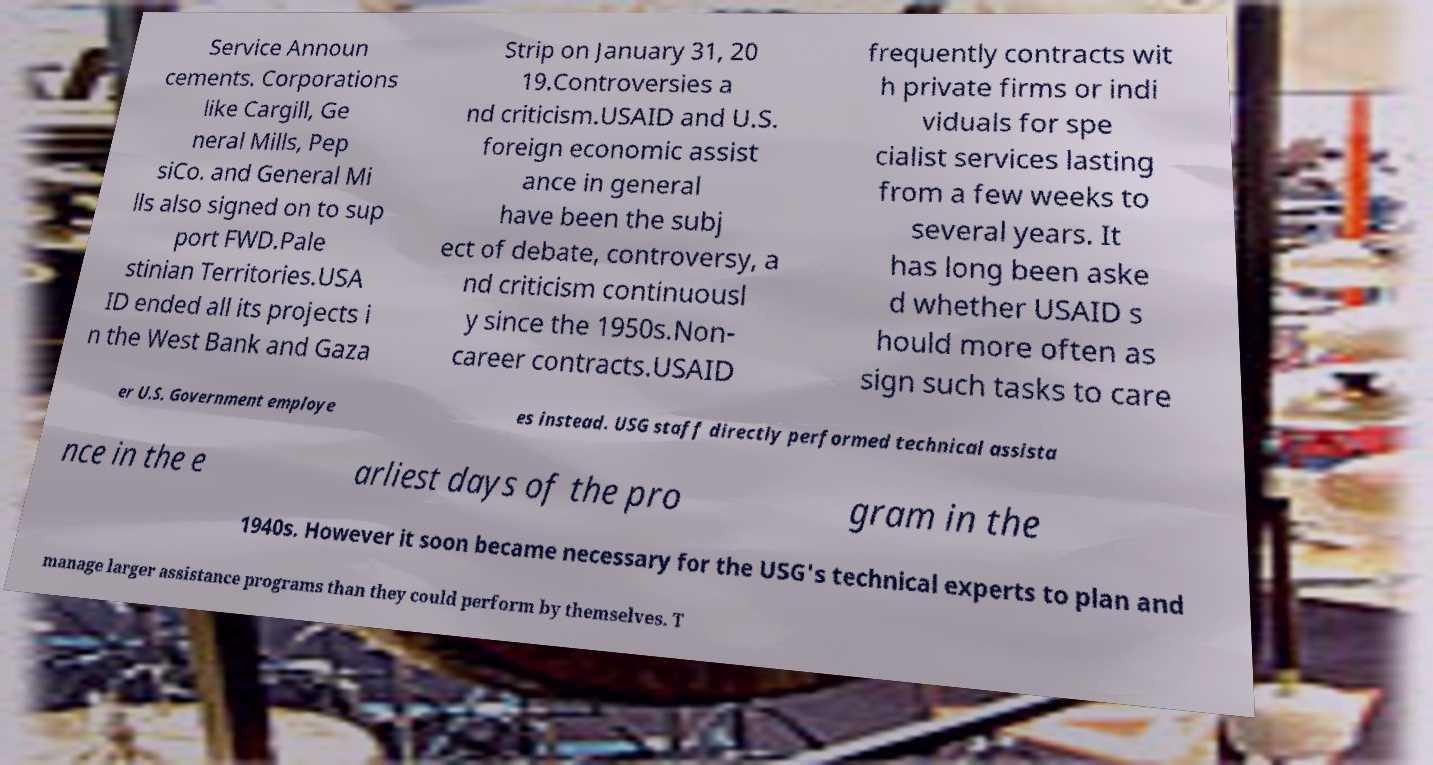I need the written content from this picture converted into text. Can you do that? Service Announ cements. Corporations like Cargill, Ge neral Mills, Pep siCo. and General Mi lls also signed on to sup port FWD.Pale stinian Territories.USA ID ended all its projects i n the West Bank and Gaza Strip on January 31, 20 19.Controversies a nd criticism.USAID and U.S. foreign economic assist ance in general have been the subj ect of debate, controversy, a nd criticism continuousl y since the 1950s.Non- career contracts.USAID frequently contracts wit h private firms or indi viduals for spe cialist services lasting from a few weeks to several years. It has long been aske d whether USAID s hould more often as sign such tasks to care er U.S. Government employe es instead. USG staff directly performed technical assista nce in the e arliest days of the pro gram in the 1940s. However it soon became necessary for the USG's technical experts to plan and manage larger assistance programs than they could perform by themselves. T 